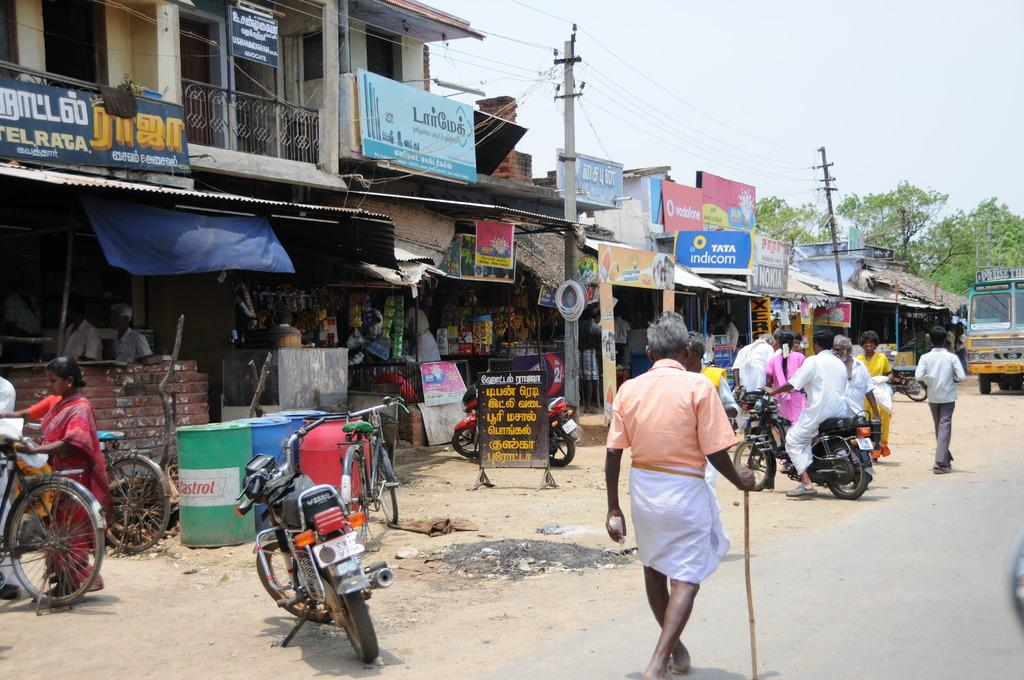What can be seen in the image in terms of transportation? There are groups of ships in the image. What else can be seen in the image besides the ships? There are groups of people in front of the shops in the image. What direction is the wheel turning in the image? There is no wheel present in the image. How many drops of water can be seen falling from the sky in the image? There is no reference to rain or water drops in the image. 